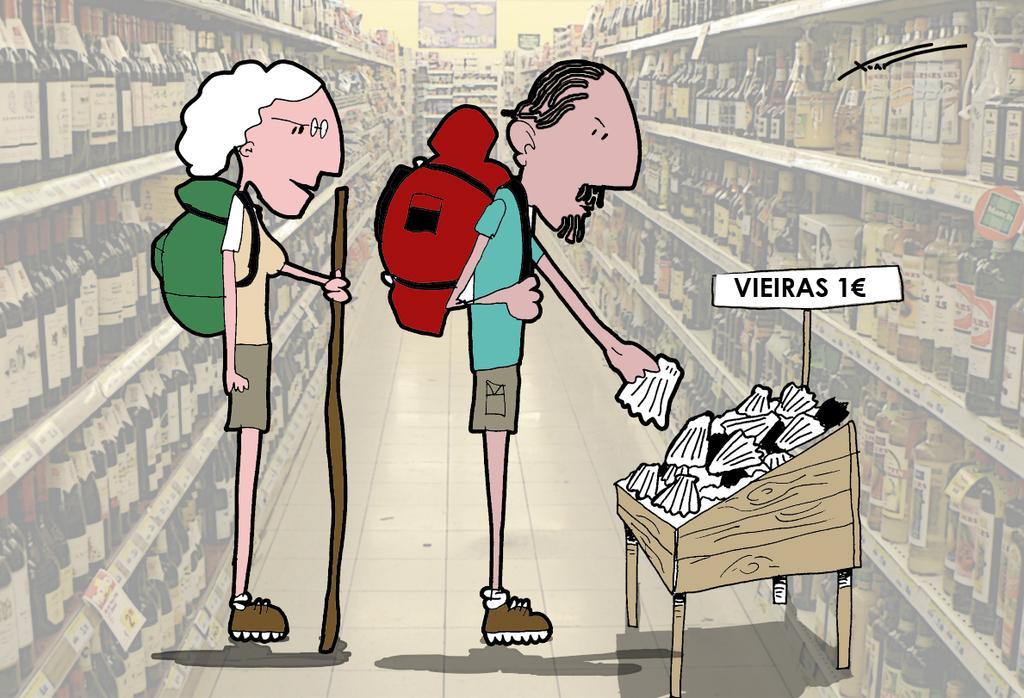In one or two sentences, can you explain what this image depicts? The picture is a cartoon sketch where there are two people and the guy is picking up a object where there is a poster on which VIERES 1 Euro is written. 